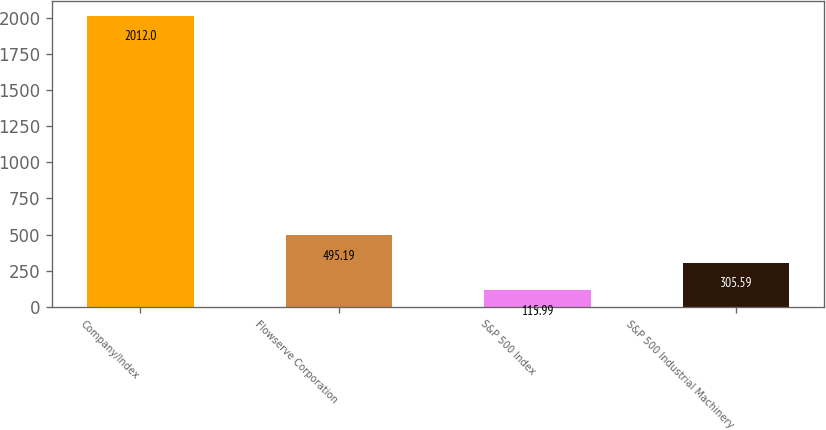Convert chart to OTSL. <chart><loc_0><loc_0><loc_500><loc_500><bar_chart><fcel>Company/Index<fcel>Flowserve Corporation<fcel>S&P 500 Index<fcel>S&P 500 Industrial Machinery<nl><fcel>2012<fcel>495.19<fcel>115.99<fcel>305.59<nl></chart> 